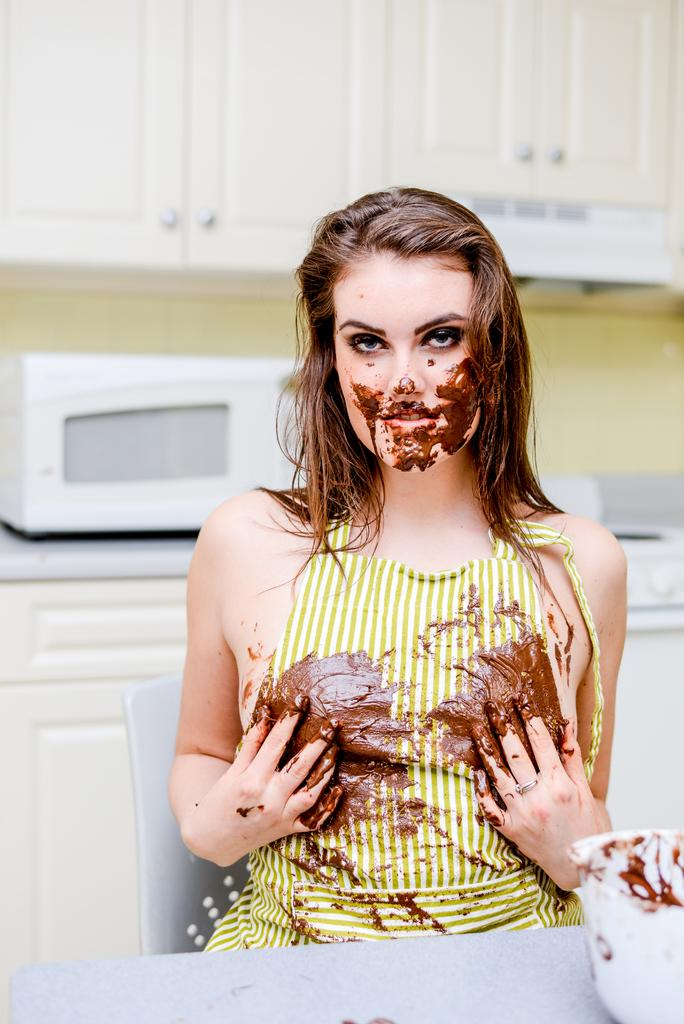Who is the main subject in the image? There is a lady in the image. What is the condition of the lady in the image? The lady has chocolate on her body and face. What is the purpose of the oven in the image? The oven on the desk in the image is likely used for cooking or baking. What type of furniture is present in the image? There are cupboards in the image. What type of locket is the lady wearing in the image? There is no locket visible on the lady in the image. What effect does the chocolate have on the lady's ability to walk in the image? The image does not show the lady walking, so it is impossible to determine the effect of the chocolate on her ability to walk. 